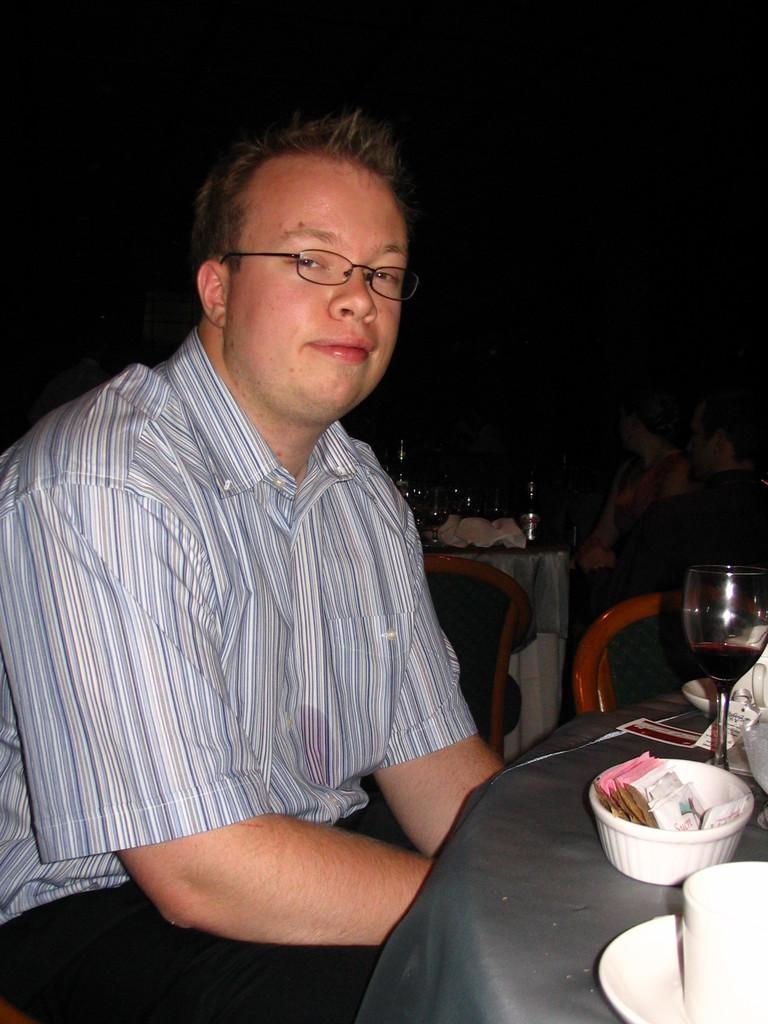Describe this image in one or two sentences. In the left side a man is sitting he wears a shirt,spectacles on the right there is a white glass and bowl and plates on the dining table. 